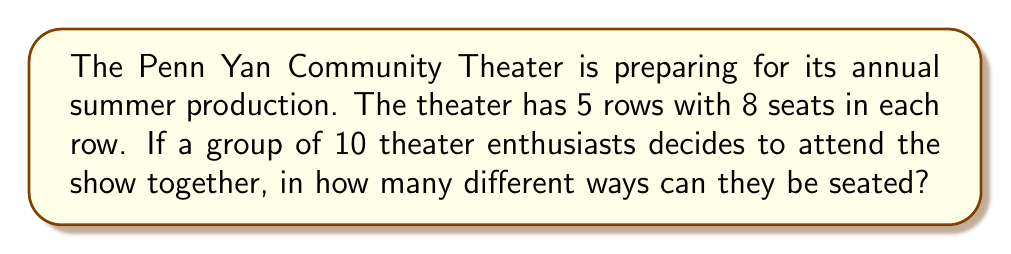Could you help me with this problem? Let's approach this step-by-step:

1) First, we need to calculate the total number of seats available:
   $5 \text{ rows} \times 8 \text{ seats per row} = 40 \text{ total seats}$

2) We are selecting 10 seats out of these 40 seats. This is a combination problem.

3) The formula for combinations is:

   $$C(n,r) = \frac{n!}{r!(n-r)!}$$

   where $n$ is the total number of items to choose from, and $r$ is the number of items being chosen.

4) In this case, $n = 40$ and $r = 10$. So we have:

   $$C(40,10) = \frac{40!}{10!(40-10)!} = \frac{40!}{10!30!}$$

5) This gives us the number of ways to select 10 seats out of 40.

6) However, once the seats are selected, the 10 people can arrange themselves in these seats in $10!$ ways.

7) Therefore, the total number of seating arrangements is:

   $$\frac{40!}{10!30!} \times 10!$$

8) The $10!$ cancels out in the numerator and denominator:

   $$\frac{40!}{30!}$$

9) This can be calculated as:

   $$40 \times 39 \times 38 \times 37 \times 36 \times 35 \times 34 \times 33 \times 32 \times 31 = 847,660,528,000$$
Answer: 847,660,528,000 